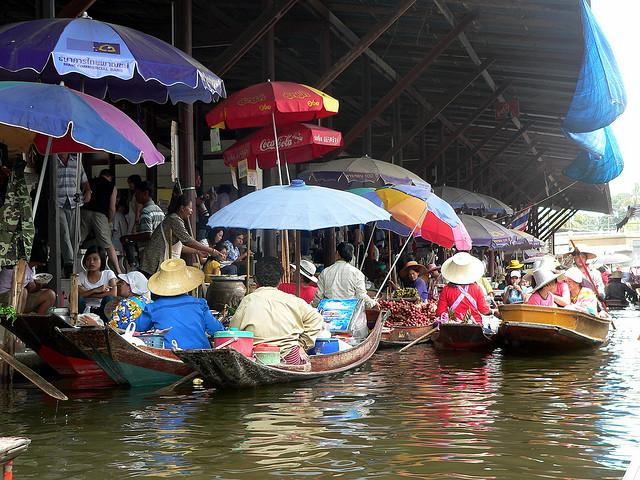What is the woman with a big blue umbrella doing? sailing 